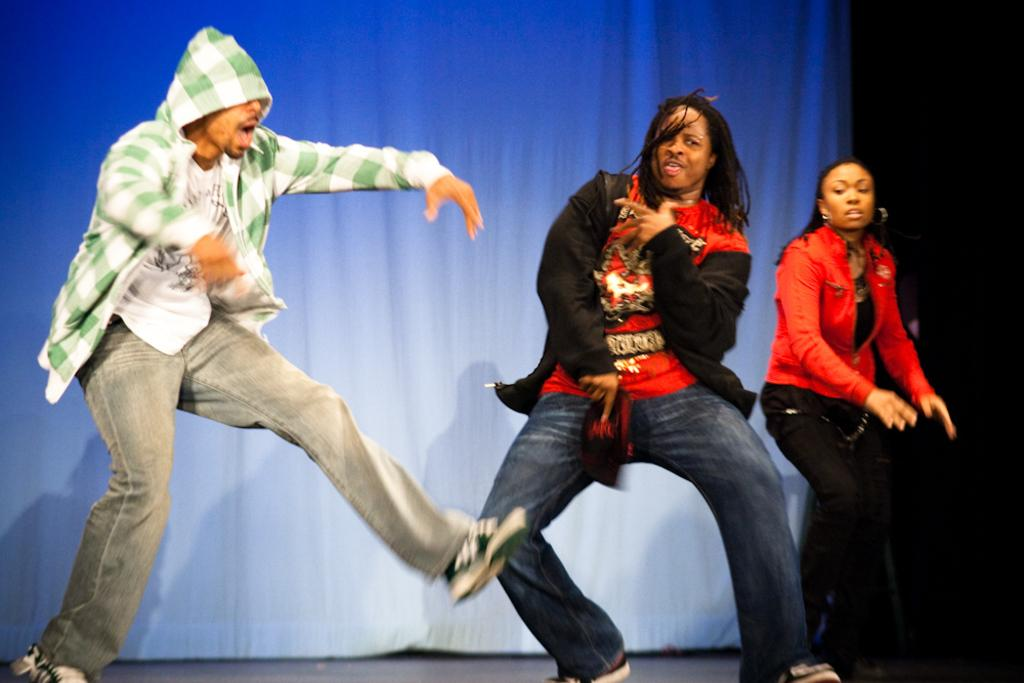What is happening in the image? There are three persons performing in the image. How can we differentiate the performers in the image? The persons are in different costumes. What can be seen in the background of the image? There is a curtain in the background of the image. What type of plate is being used by the cattle in the image? There are no cattle or plates present in the image; it features three persons performing in different costumes. 